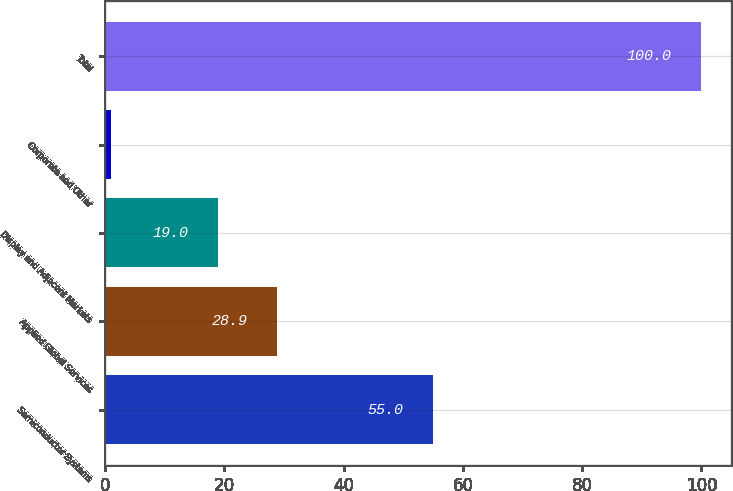<chart> <loc_0><loc_0><loc_500><loc_500><bar_chart><fcel>Semiconductor Systems<fcel>Applied Global Services<fcel>Display and Adjacent Markets<fcel>Corporate and Other<fcel>Total<nl><fcel>55<fcel>28.9<fcel>19<fcel>1<fcel>100<nl></chart> 